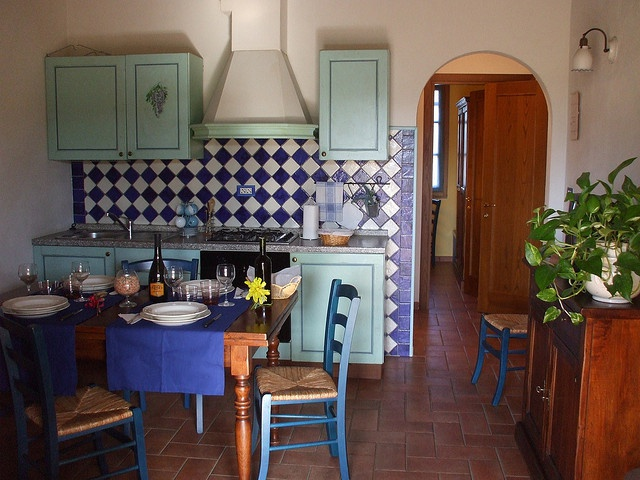Describe the objects in this image and their specific colors. I can see potted plant in brown, black, darkgreen, and maroon tones, dining table in brown, navy, black, and blue tones, chair in brown, black, maroon, and navy tones, chair in brown, maroon, gray, and black tones, and oven in brown, black, and gray tones in this image. 